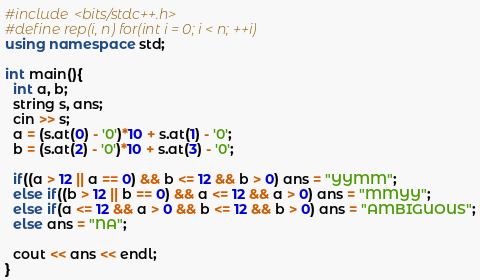Convert code to text. <code><loc_0><loc_0><loc_500><loc_500><_C++_>#include <bits/stdc++.h>
#define rep(i, n) for(int i = 0; i < n; ++i)
using namespace std;

int main(){
  int a, b;
  string s, ans;
  cin >> s;
  a = (s.at(0) - '0')*10 + s.at(1) - '0';
  b = (s.at(2) - '0')*10 + s.at(3) - '0';
  
  if((a > 12 || a == 0) && b <= 12 && b > 0) ans = "YYMM";
  else if((b > 12 || b == 0) && a <= 12 && a > 0) ans = "MMYY";
  else if(a <= 12 && a > 0 && b <= 12 && b > 0) ans = "AMBIGUOUS";
  else ans = "NA";
  
  cout << ans << endl;
}</code> 